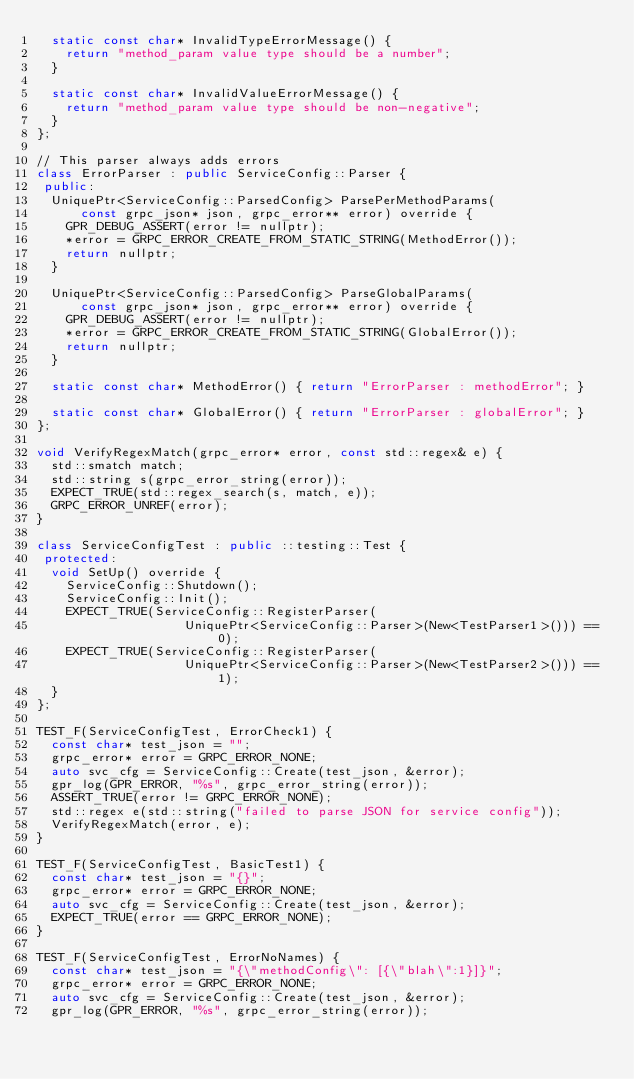<code> <loc_0><loc_0><loc_500><loc_500><_C++_>  static const char* InvalidTypeErrorMessage() {
    return "method_param value type should be a number";
  }

  static const char* InvalidValueErrorMessage() {
    return "method_param value type should be non-negative";
  }
};

// This parser always adds errors
class ErrorParser : public ServiceConfig::Parser {
 public:
  UniquePtr<ServiceConfig::ParsedConfig> ParsePerMethodParams(
      const grpc_json* json, grpc_error** error) override {
    GPR_DEBUG_ASSERT(error != nullptr);
    *error = GRPC_ERROR_CREATE_FROM_STATIC_STRING(MethodError());
    return nullptr;
  }

  UniquePtr<ServiceConfig::ParsedConfig> ParseGlobalParams(
      const grpc_json* json, grpc_error** error) override {
    GPR_DEBUG_ASSERT(error != nullptr);
    *error = GRPC_ERROR_CREATE_FROM_STATIC_STRING(GlobalError());
    return nullptr;
  }

  static const char* MethodError() { return "ErrorParser : methodError"; }

  static const char* GlobalError() { return "ErrorParser : globalError"; }
};

void VerifyRegexMatch(grpc_error* error, const std::regex& e) {
  std::smatch match;
  std::string s(grpc_error_string(error));
  EXPECT_TRUE(std::regex_search(s, match, e));
  GRPC_ERROR_UNREF(error);
}

class ServiceConfigTest : public ::testing::Test {
 protected:
  void SetUp() override {
    ServiceConfig::Shutdown();
    ServiceConfig::Init();
    EXPECT_TRUE(ServiceConfig::RegisterParser(
                    UniquePtr<ServiceConfig::Parser>(New<TestParser1>())) == 0);
    EXPECT_TRUE(ServiceConfig::RegisterParser(
                    UniquePtr<ServiceConfig::Parser>(New<TestParser2>())) == 1);
  }
};

TEST_F(ServiceConfigTest, ErrorCheck1) {
  const char* test_json = "";
  grpc_error* error = GRPC_ERROR_NONE;
  auto svc_cfg = ServiceConfig::Create(test_json, &error);
  gpr_log(GPR_ERROR, "%s", grpc_error_string(error));
  ASSERT_TRUE(error != GRPC_ERROR_NONE);
  std::regex e(std::string("failed to parse JSON for service config"));
  VerifyRegexMatch(error, e);
}

TEST_F(ServiceConfigTest, BasicTest1) {
  const char* test_json = "{}";
  grpc_error* error = GRPC_ERROR_NONE;
  auto svc_cfg = ServiceConfig::Create(test_json, &error);
  EXPECT_TRUE(error == GRPC_ERROR_NONE);
}

TEST_F(ServiceConfigTest, ErrorNoNames) {
  const char* test_json = "{\"methodConfig\": [{\"blah\":1}]}";
  grpc_error* error = GRPC_ERROR_NONE;
  auto svc_cfg = ServiceConfig::Create(test_json, &error);
  gpr_log(GPR_ERROR, "%s", grpc_error_string(error));</code> 